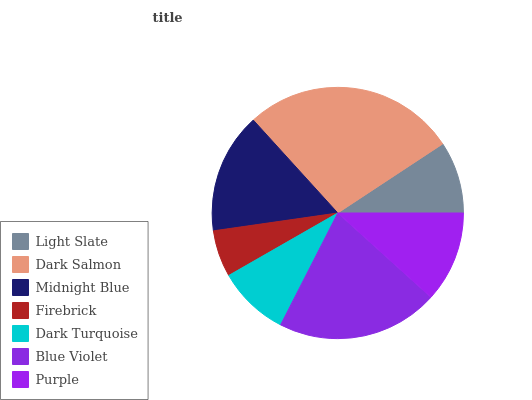Is Firebrick the minimum?
Answer yes or no. Yes. Is Dark Salmon the maximum?
Answer yes or no. Yes. Is Midnight Blue the minimum?
Answer yes or no. No. Is Midnight Blue the maximum?
Answer yes or no. No. Is Dark Salmon greater than Midnight Blue?
Answer yes or no. Yes. Is Midnight Blue less than Dark Salmon?
Answer yes or no. Yes. Is Midnight Blue greater than Dark Salmon?
Answer yes or no. No. Is Dark Salmon less than Midnight Blue?
Answer yes or no. No. Is Purple the high median?
Answer yes or no. Yes. Is Purple the low median?
Answer yes or no. Yes. Is Light Slate the high median?
Answer yes or no. No. Is Dark Turquoise the low median?
Answer yes or no. No. 